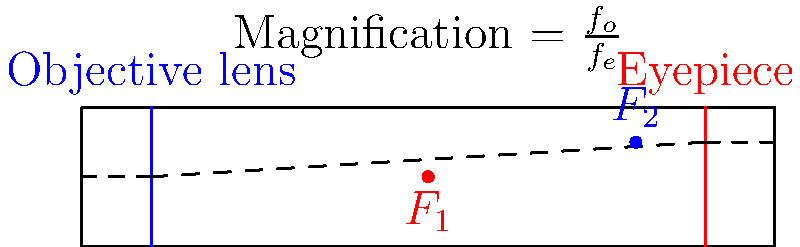In a refracting telescope, the objective lens creates a real image of a distant object near the focal point of the eyepiece. How does this arrangement contribute to the magnification of the image, and what is the formula for calculating the magnification power of such a telescope? To understand how a refracting telescope magnifies distant objects, let's break down the process:

1. The objective lens (primary lens) collects light from the distant object and forms a real image near its focal point ($F_1$).

2. This real image is located at or near the focal point of the eyepiece ($F_2$).

3. The eyepiece then acts as a magnifying glass, allowing the observer to view this image as if it were much closer.

4. The magnification of the telescope is determined by the ratio of the focal lengths of the objective lens ($f_o$) and the eyepiece ($f_e$).

5. The formula for calculating the magnification (M) is:

   $$ M = \frac{f_o}{f_e} $$

6. This ratio essentially compares how much the objective lens "brings in" the image to how much the eyepiece magnifies it.

7. A longer focal length for the objective lens or a shorter focal length for the eyepiece will result in greater magnification.

8. However, increasing magnification also decreases the field of view and the amount of light gathered, so there's a practical limit to how much magnification is useful.

This arrangement allows astronomers to observe distant celestial objects in much greater detail than would be possible with the naked eye, making refracting telescopes invaluable tools in astronomical research and exploration.
Answer: $M = \frac{f_o}{f_e}$, where $f_o$ is the focal length of the objective lens and $f_e$ is the focal length of the eyepiece. 